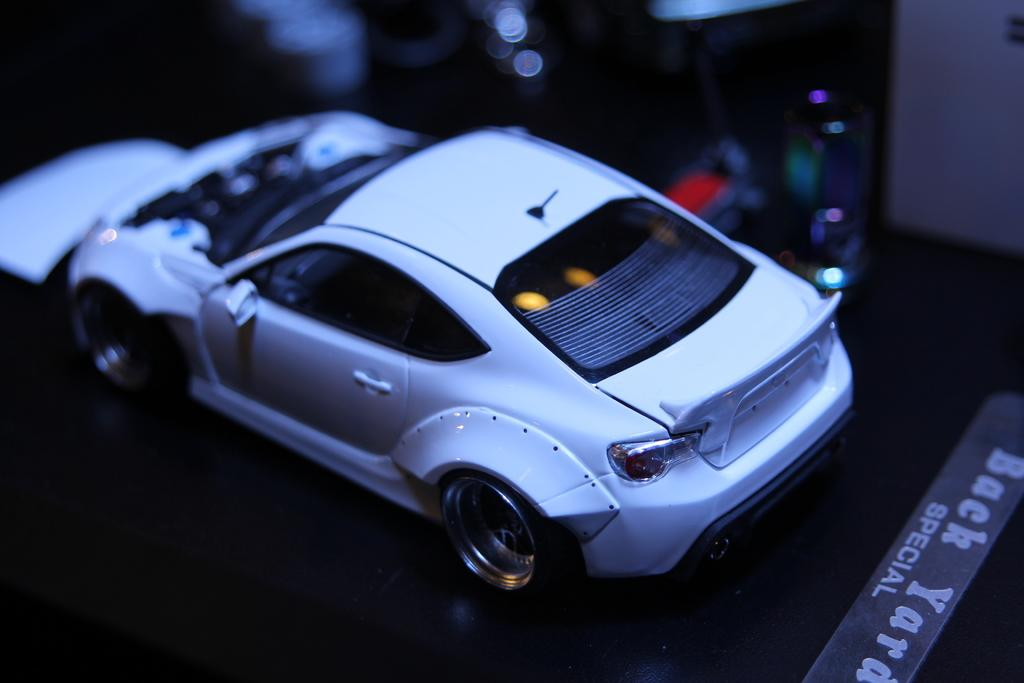What is the main object in the image? There is a toy car in the image. Where is the toy car located? The toy car is on a table. What color is the toy car? The toy car is white in color. What type of dress is the donkey wearing in the image? There is no donkey or dress present in the image; it features a white toy car on a table. 